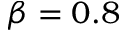Convert formula to latex. <formula><loc_0><loc_0><loc_500><loc_500>\beta = 0 . 8</formula> 